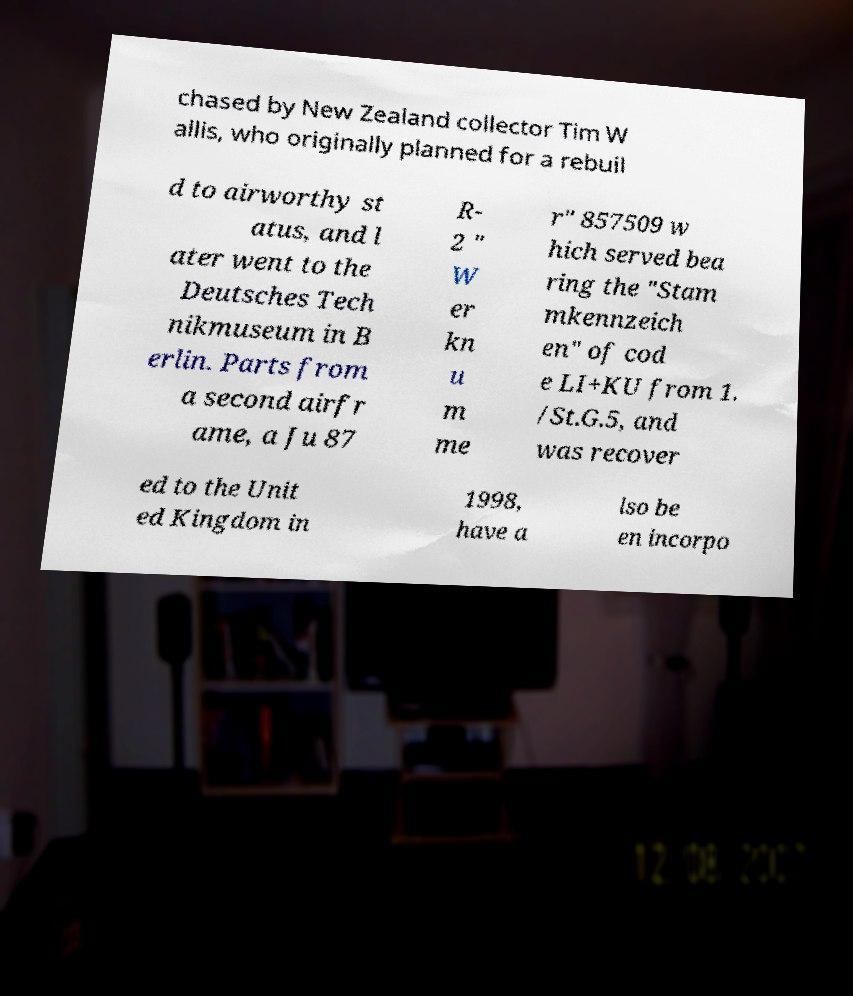Could you extract and type out the text from this image? chased by New Zealand collector Tim W allis, who originally planned for a rebuil d to airworthy st atus, and l ater went to the Deutsches Tech nikmuseum in B erlin. Parts from a second airfr ame, a Ju 87 R- 2 " W er kn u m me r" 857509 w hich served bea ring the "Stam mkennzeich en" of cod e LI+KU from 1. /St.G.5, and was recover ed to the Unit ed Kingdom in 1998, have a lso be en incorpo 